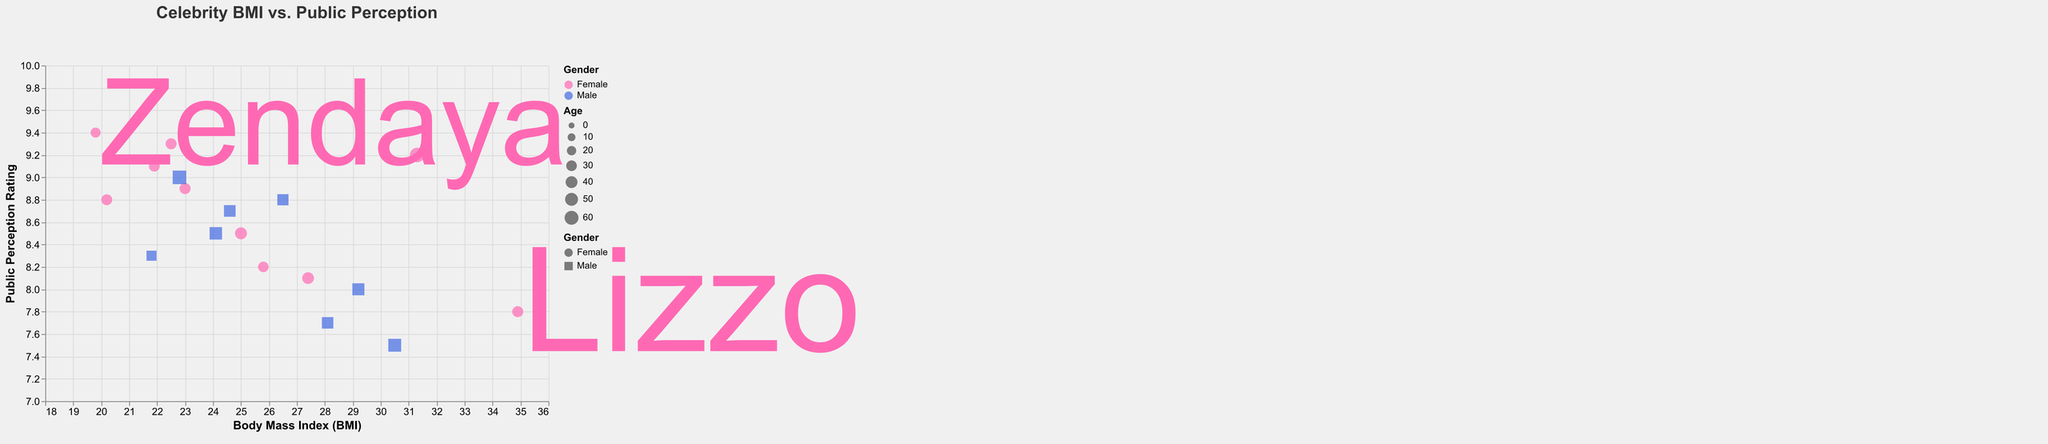What is the title of the chart? The title of the chart is written at the top and is clearly labeled.
Answer: Celebrity BMI vs. Public Perception Which celebrity has the highest Public Perception Rating, and what is their BMI? By looking for the highest y-axis value, we see it corresponds to Zendaya. Examining the x-axis, Zendaya's BMI is 19.8.
Answer: Zendaya, 19.8 How does the Public Perception Rating of Jason Momoa compare to Jonah Hill? Locate the points for Jason Momoa and Jonah Hill and compare their positions on the y-axis. Jason Momoa has a higher rating (8.0) than Jonah Hill (7.7).
Answer: Jason Momoa has a higher rating What is the general trend between BMI and Public Perception Rating among male celebrities? Observe the scatter points for 'Male' and look for any patterns. Generally, lower BMI correlates with higher Public Perception Ratings among male celebrities.
Answer: Lower BMI tends to higher perception How does Adele's Public Perception Rating compare to that of Kelly Clarkson? Locate Adele and Kelly Clarkson on the plot and compare their y-axis positions. Adele's rating is 9.3, while Kelly Clarkson's rating is 8.1.
Answer: Adele has a higher rating Which female celebrity in their 30s has the highest Public Perception Rating, and what is the value? Filter the points to those labeled 'Female' and aged '30-39', then find the highest y-axis value among them. Rihanna, aged 33, has the highest at 8.9.
Answer: Rihanna, 8.9 Compare the BMIs of the oldest and youngest celebrities on the chart. What are they? The oldest is Oprah Winfrey (67, BMI 31.3) and the youngest is Zendaya (25, BMI 19.8).
Answer: Oprah, 31.3 and Zendaya, 19.8 What is the range of BMIs for male celebrities in their 40s? Identify male celebrities in their 40s and note their BMI values: Dwayne Johnson (30.5), Jason Momoa (29.2), Leonardo DiCaprio (24.1). The range is maximum (30.5) minus minimum (24.1).
Answer: 30.5 - 24.1 = 6.4 Which gender has a higher average Public Perception Rating? Sum the ratings for male and female celebrities and divide by their respective counts. Sum of Male ratings: 50.7, count: 8. Sum of Female ratings: 71.0, count: 10. Calculate averages (50.7/8 = 6.3 vs 71.0/10 = 7.1).
Answer: Female Is there a correlation between BMI and Public Perception Rating for male celebrities? Look for a relationship pattern among male points. Generally, male points show a trend where lower BMI corresponds to higher perception ratings.
Answer: Negative correlation 